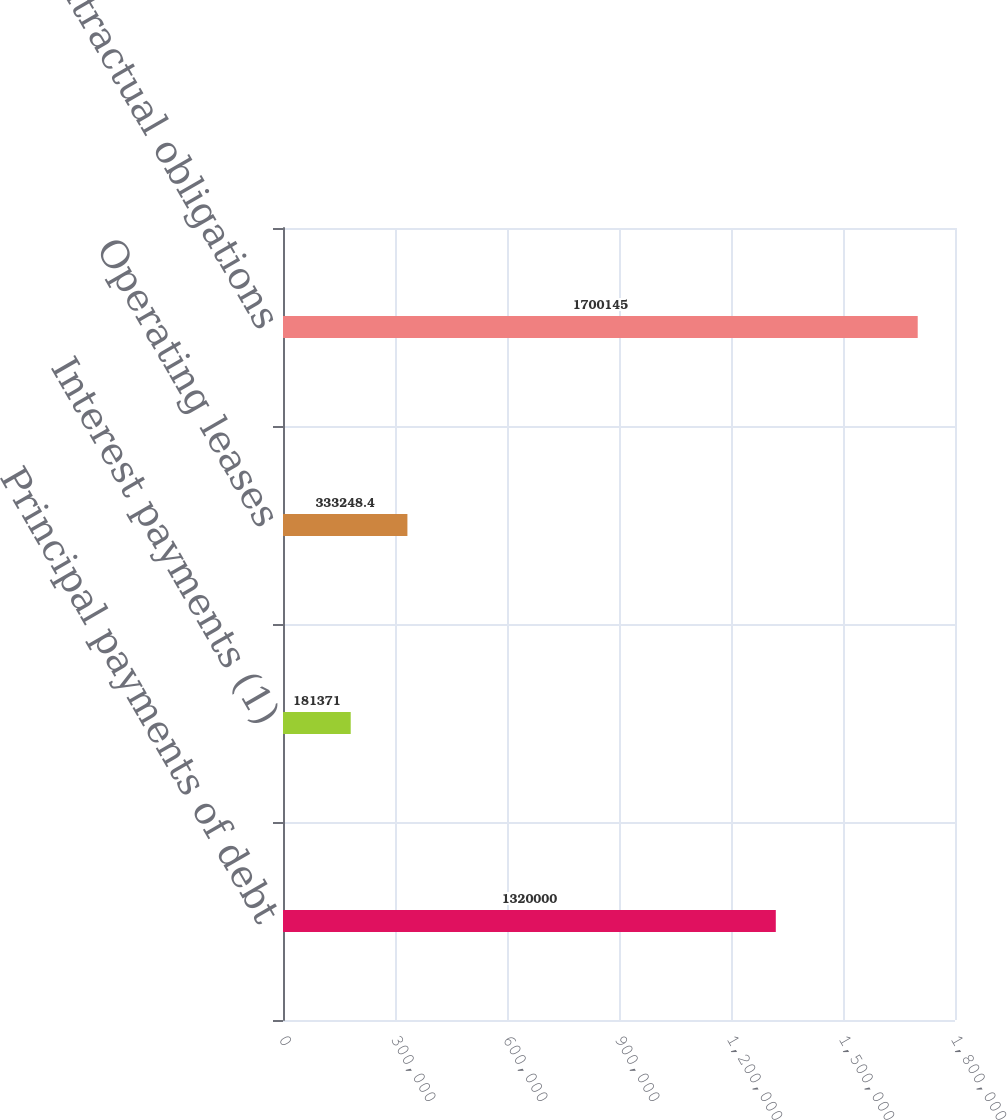<chart> <loc_0><loc_0><loc_500><loc_500><bar_chart><fcel>Principal payments of debt<fcel>Interest payments (1)<fcel>Operating leases<fcel>Total contractual obligations<nl><fcel>1.32e+06<fcel>181371<fcel>333248<fcel>1.70014e+06<nl></chart> 